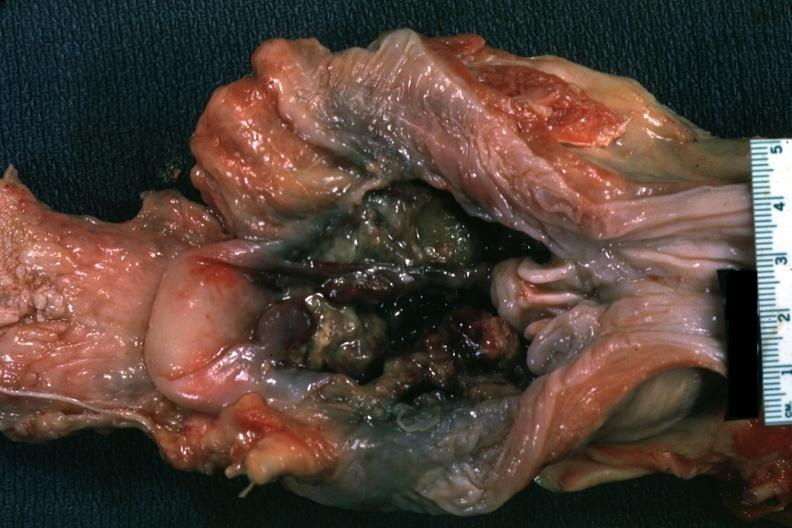s carcinoma present?
Answer the question using a single word or phrase. Yes 